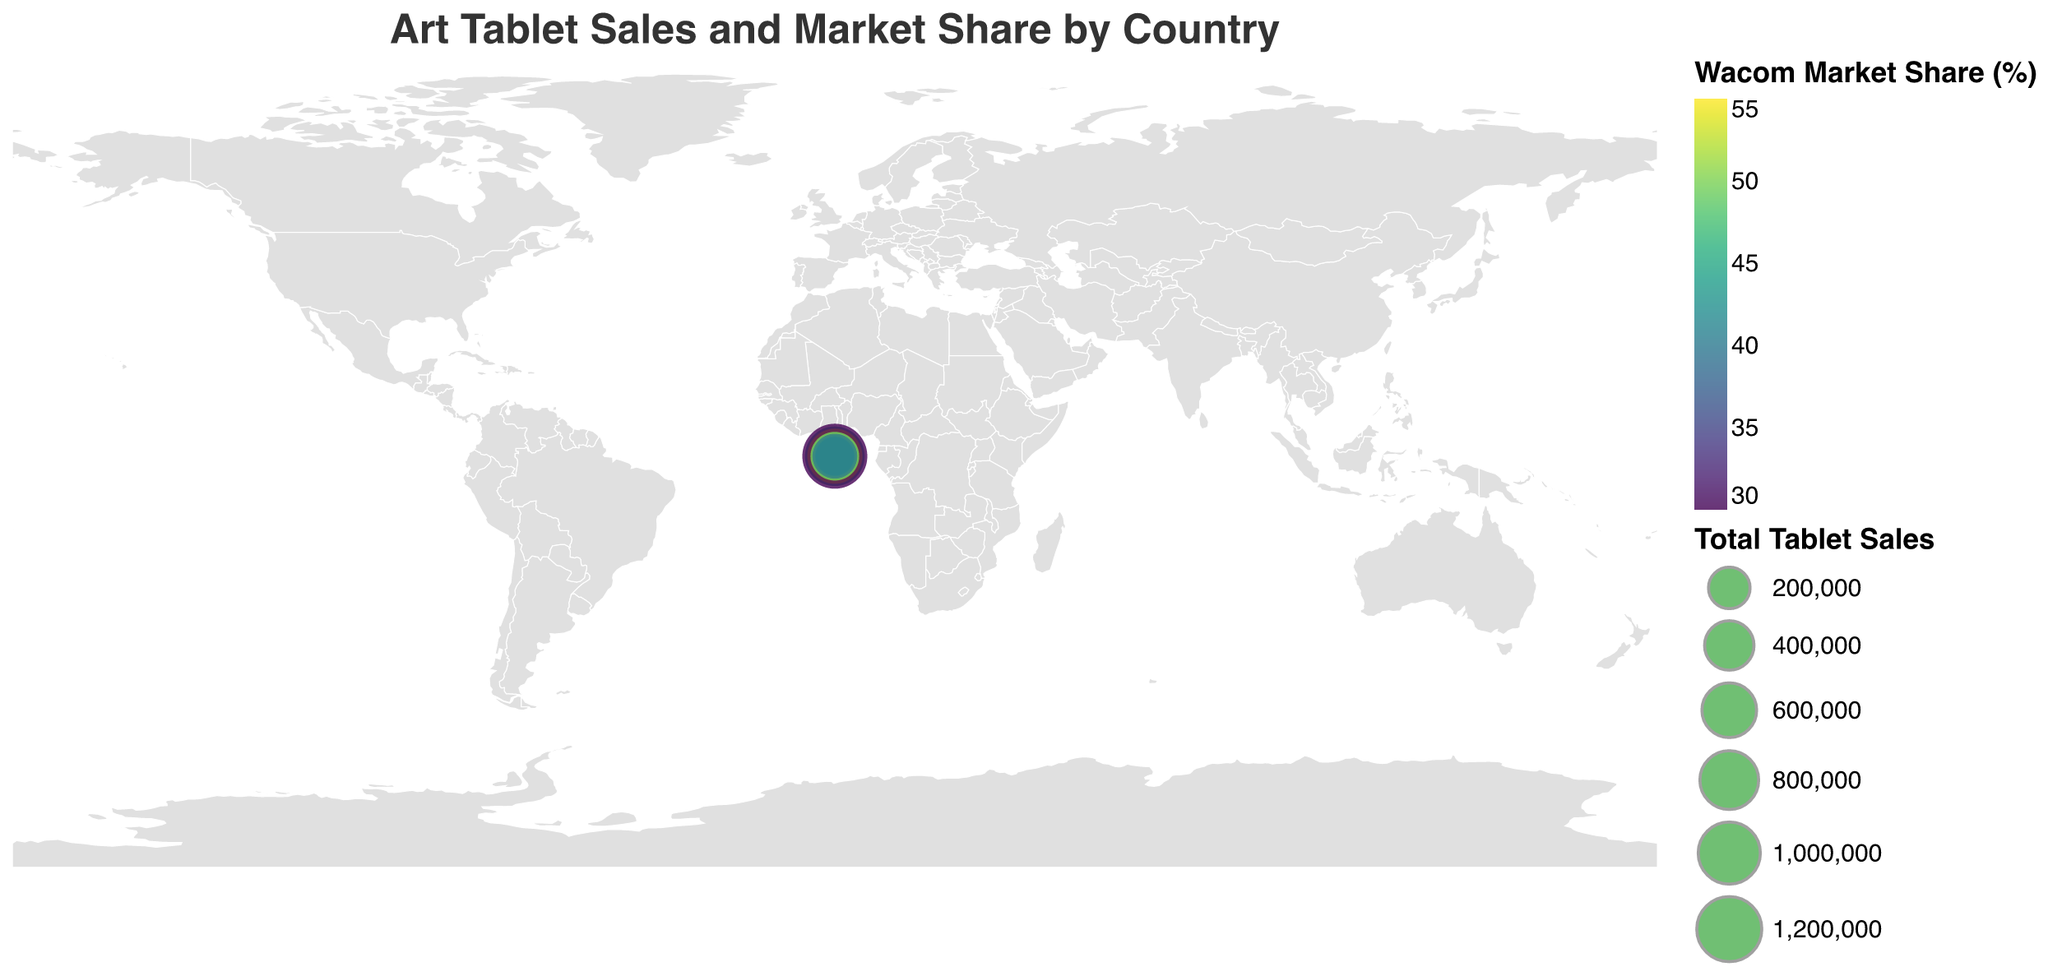what is the title of the figure? The title is located at the top of the figure and is clearly marked to provide context about what the figure represents. The title reads, "Art Tablet Sales and Market Share by Country."
Answer: Art Tablet Sales and Market Share by Country Which country has the highest total tablet sales? The size of the circles in the figure represents the total tablet sales, and the largest circle corresponds to China. It's indicated in the tooltip that China has the highest total sales with 1,200,000 units.
Answer: China What is the market share of Wacom in Japan? By hovering over Japan in the figure, the tooltip displays various statistics, including the Wacom market share, which is 55%.
Answer: 55% Which two countries have the closest total tablet sales? From the figure, the United Kingdom and South Korea have similarly sized circles, indicating their total tablet sales are close. The tooltip confirms they are 320,000 and 290,000 units respectively, resulting in a difference of only 30,000 units.
Answer: United Kingdom and South Korea What is the difference in Huion market share between the United States and China? By looking at the Huion market share values in the tooltip for the United States (30%) and China (40%), we subtract 30 from 40 to find the difference.
Answer: 10% Which country has the highest Wacom market share, and what is it? By examining the color coding in the legend and tooltip values, Japan has the highest Wacom market share, shown as deeper colored areas representing 55%.
Answer: Japan, 55% How does the Huion market share in Brazil compare to that in Australia? The tooltip for Brazil shows Huion market share as 35%, and Australia shows 31%. By comparing these values, Brazil's share is greater by 4%.
Answer: Brazil has a greater Huion market share by 4% Which country has the lowest XP-Pen market share? By looking at the XP-Pen market share in the tooltip for each country, Japan has the lowest share at 10%.
Answer: Japan What is the total tablet sales for the United Kingdom and France combined? The tooltip shows the United Kingdom with 320,000 and France with 220,000 total tablet sales. Adding these values gives a total of 540,000 units.
Answer: 540,000 Which country has the smallest number of total tablet sales and what is it? The smallest circle on the map corresponds to Australia, and the tooltip indicates that Australia has 150,000 total tablet sales.
Answer: Australia, 150,000 